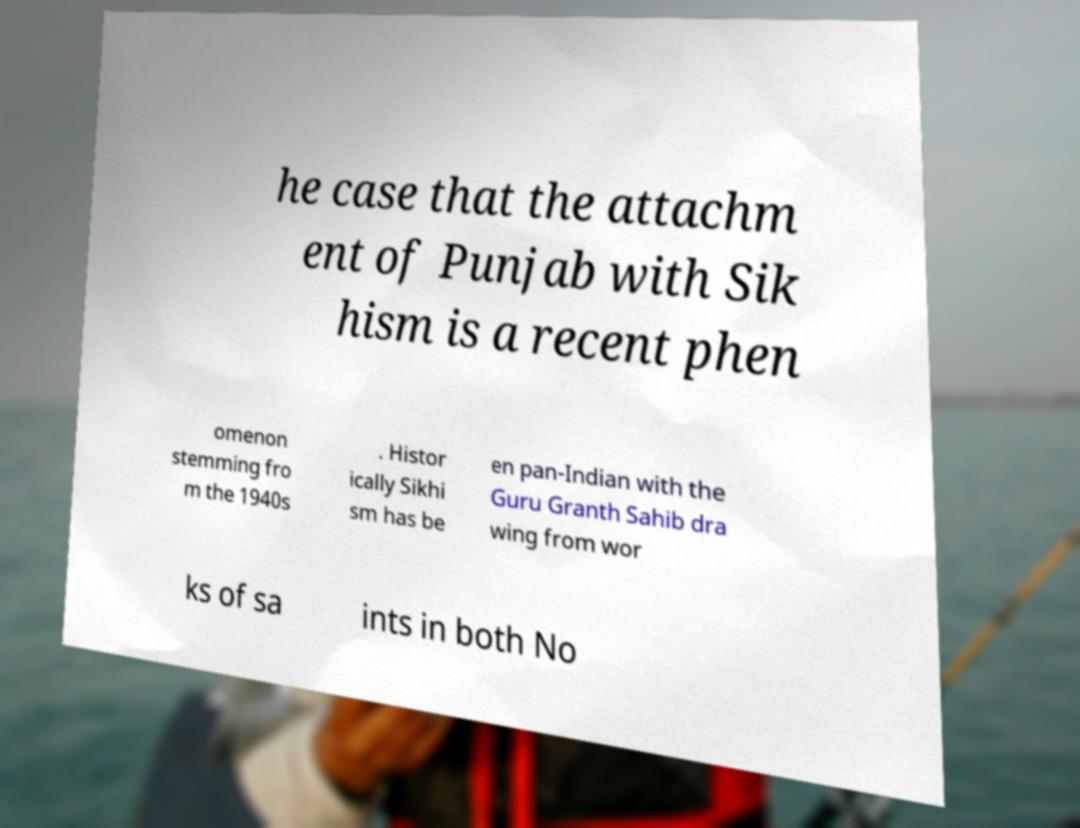Could you extract and type out the text from this image? he case that the attachm ent of Punjab with Sik hism is a recent phen omenon stemming fro m the 1940s . Histor ically Sikhi sm has be en pan-Indian with the Guru Granth Sahib dra wing from wor ks of sa ints in both No 